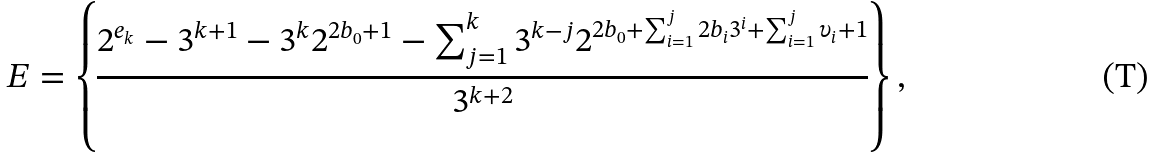<formula> <loc_0><loc_0><loc_500><loc_500>E = \left \{ \frac { 2 ^ { e _ { k } } - 3 ^ { k + 1 } - 3 ^ { k } 2 ^ { 2 b _ { 0 } + 1 } - \sum \nolimits _ { j = 1 } ^ { k } 3 ^ { k - j } 2 ^ { 2 b _ { 0 } + \sum \nolimits _ { i = 1 } ^ { j } 2 b _ { i } 3 ^ { i } + \sum \nolimits _ { i = 1 } ^ { j } \upsilon _ { i } + 1 } } { 3 ^ { k + 2 } } \right \} ,</formula> 